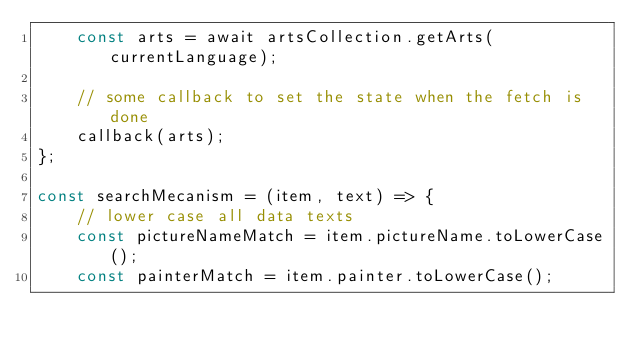Convert code to text. <code><loc_0><loc_0><loc_500><loc_500><_JavaScript_>    const arts = await artsCollection.getArts(currentLanguage);

    // some callback to set the state when the fetch is done
    callback(arts);
};

const searchMecanism = (item, text) => {
    // lower case all data texts
    const pictureNameMatch = item.pictureName.toLowerCase();
    const painterMatch = item.painter.toLowerCase();</code> 